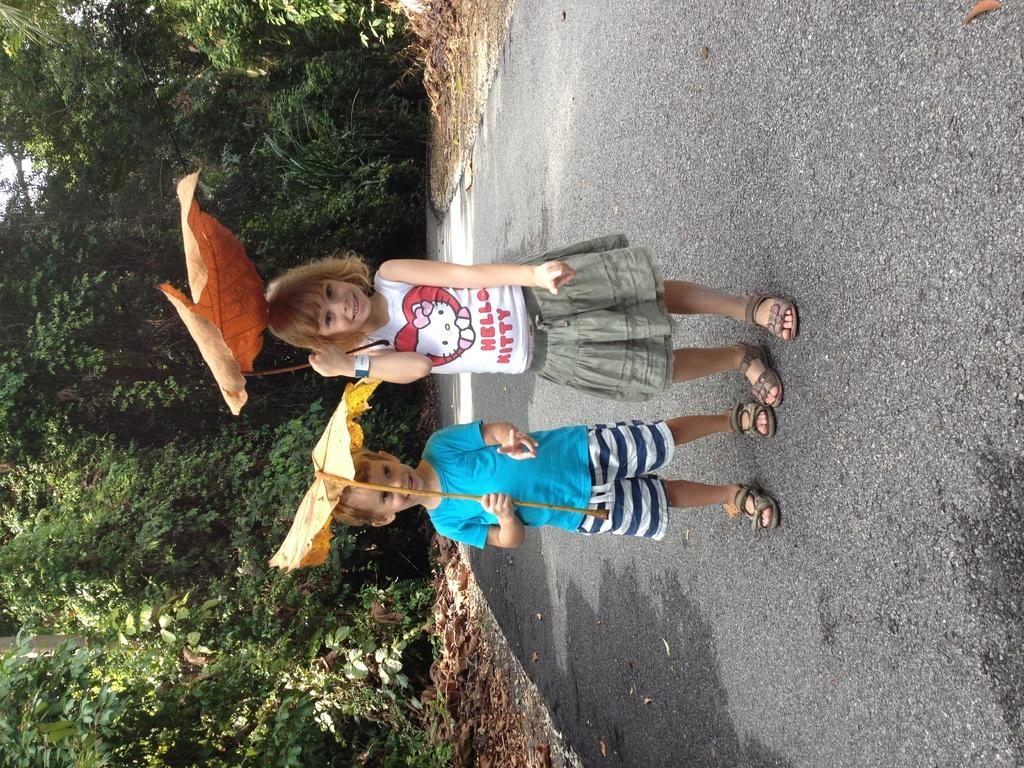<image>
Write a terse but informative summary of the picture. Two young children smile as they hold giant leaves over their heads, the girl in a Hello Kitty shirt. 